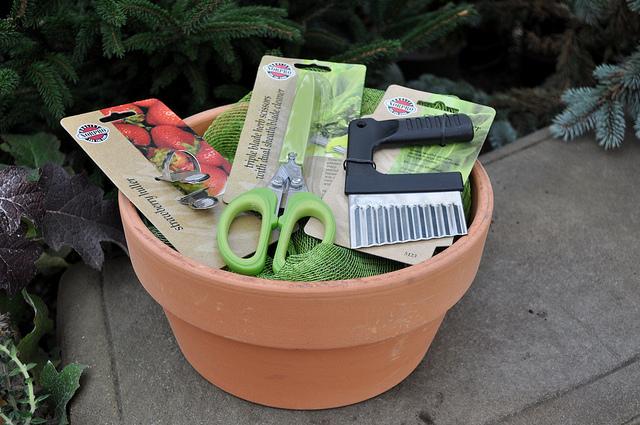How many scissors are there?
Short answer required. 1. What color are the scissors?
Write a very short answer. Green. What is holding the items?
Short answer required. Pot. How do the shears differ from the other objects in the container?
Be succinct. Green. Where are the strawberry seeds?
Quick response, please. In pot. 